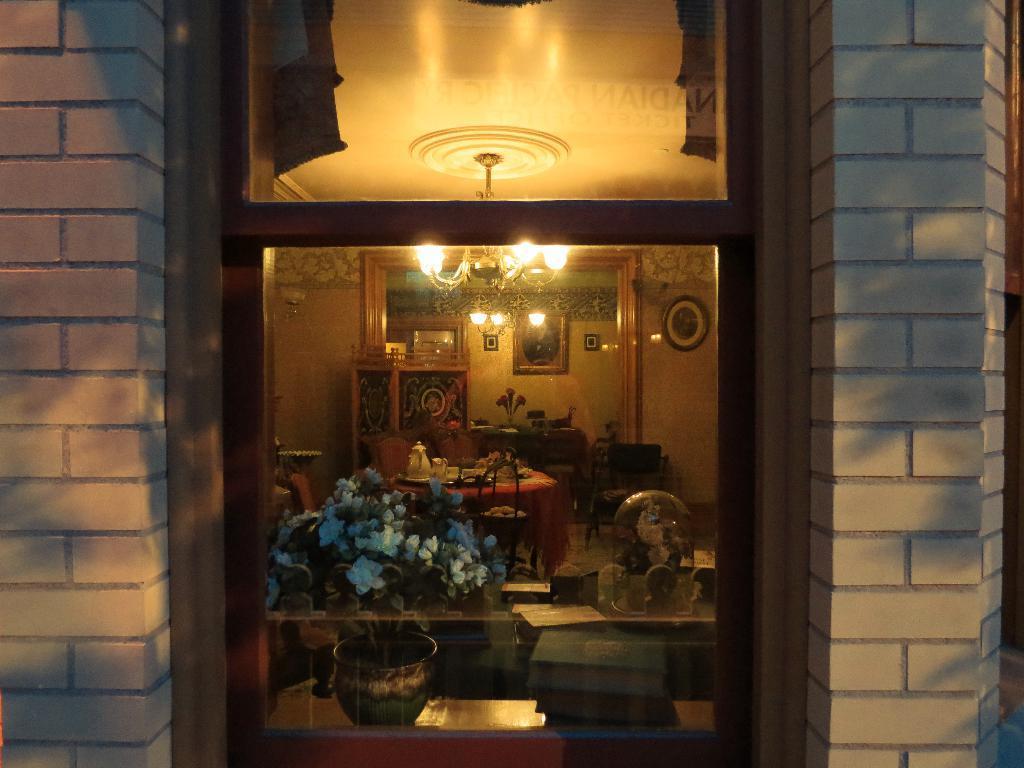Can you describe this image briefly? In this image, we can see a wall and there is a window, through the glass we can see flower vases, books and some decor items and there are chairs, tables and some other objects and a stand, mirror and a clock on the wall. At the top, there are lights. 